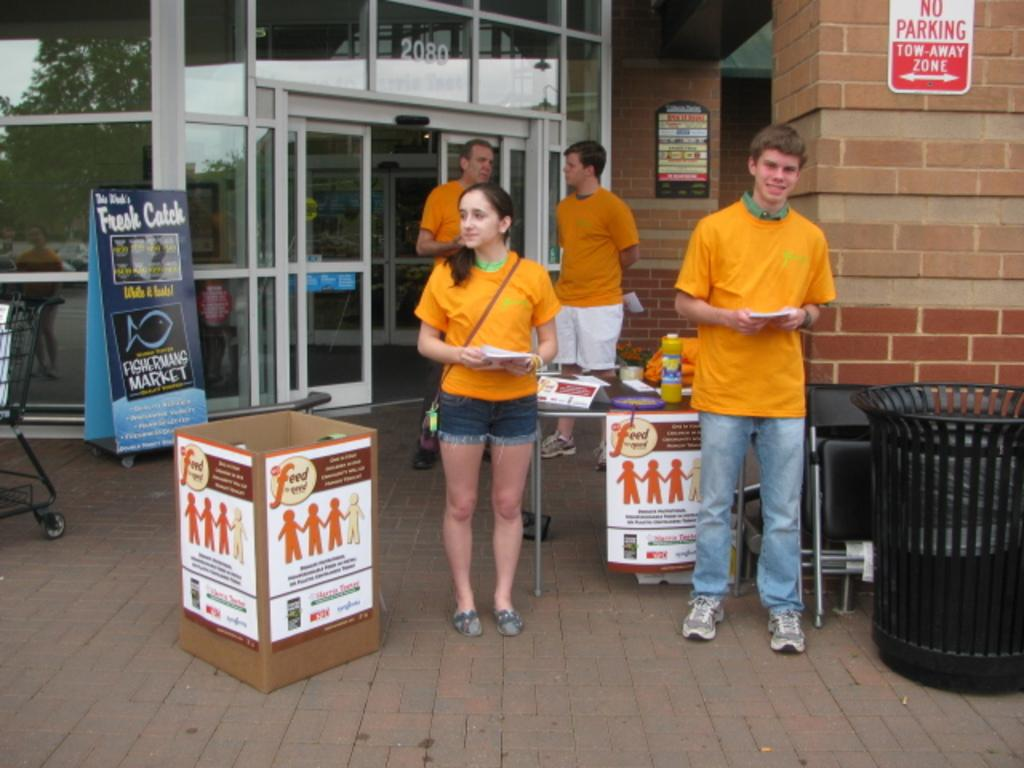<image>
Provide a brief description of the given image. a two away zone that is behind some people 